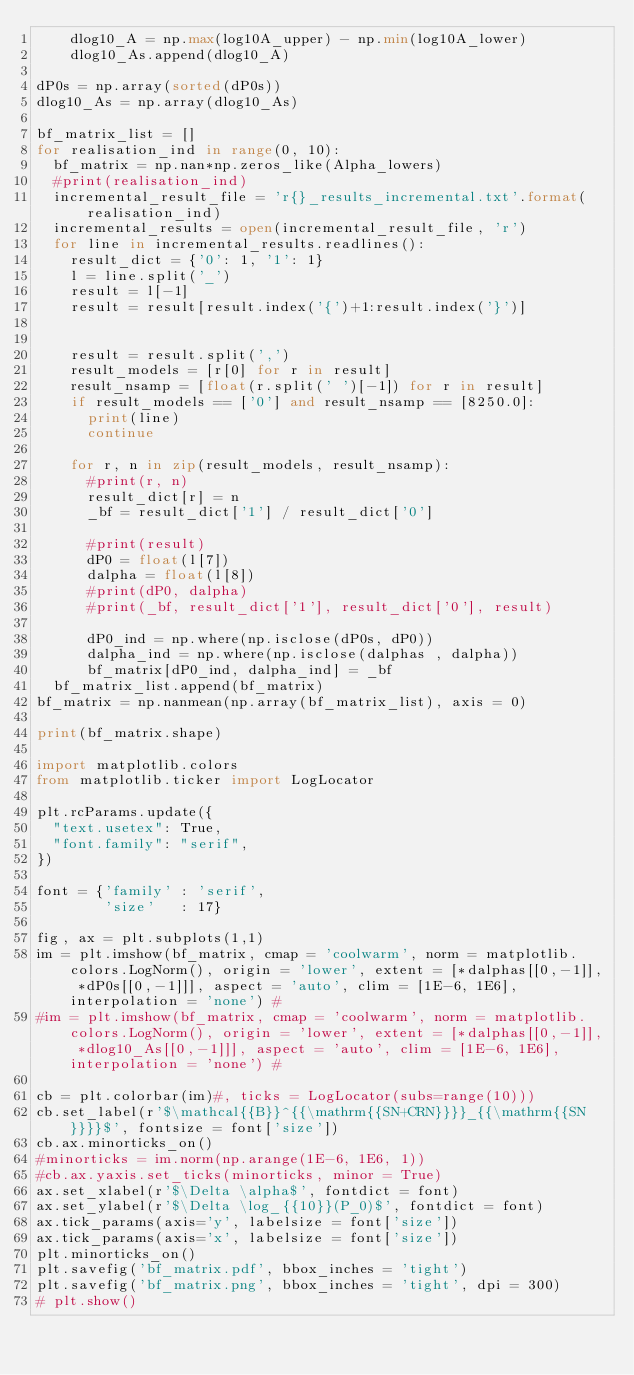Convert code to text. <code><loc_0><loc_0><loc_500><loc_500><_Python_>    dlog10_A = np.max(log10A_upper) - np.min(log10A_lower)
    dlog10_As.append(dlog10_A)

dP0s = np.array(sorted(dP0s))
dlog10_As = np.array(dlog10_As)

bf_matrix_list = []
for realisation_ind in range(0, 10):
  bf_matrix = np.nan*np.zeros_like(Alpha_lowers)
  #print(realisation_ind)
  incremental_result_file = 'r{}_results_incremental.txt'.format(realisation_ind)
  incremental_results = open(incremental_result_file, 'r')
  for line in incremental_results.readlines():
    result_dict = {'0': 1, '1': 1}
    l = line.split('_')
    result = l[-1]
    result = result[result.index('{')+1:result.index('}')]


    result = result.split(',')
    result_models = [r[0] for r in result]
    result_nsamp = [float(r.split(' ')[-1]) for r in result]
    if result_models == ['0'] and result_nsamp == [8250.0]:
      print(line)
      continue

    for r, n in zip(result_models, result_nsamp):
      #print(r, n)
      result_dict[r] = n
      _bf = result_dict['1'] / result_dict['0']

      #print(result)
      dP0 = float(l[7])
      dalpha = float(l[8])
      #print(dP0, dalpha)
      #print(_bf, result_dict['1'], result_dict['0'], result)

      dP0_ind = np.where(np.isclose(dP0s, dP0))
      dalpha_ind = np.where(np.isclose(dalphas , dalpha))
      bf_matrix[dP0_ind, dalpha_ind] = _bf
  bf_matrix_list.append(bf_matrix)
bf_matrix = np.nanmean(np.array(bf_matrix_list), axis = 0)

print(bf_matrix.shape)

import matplotlib.colors
from matplotlib.ticker import LogLocator

plt.rcParams.update({
  "text.usetex": True,
  "font.family": "serif",
})

font = {'family' : 'serif',
        'size'   : 17}

fig, ax = plt.subplots(1,1)
im = plt.imshow(bf_matrix, cmap = 'coolwarm', norm = matplotlib.colors.LogNorm(), origin = 'lower', extent = [*dalphas[[0,-1]], *dP0s[[0,-1]]], aspect = 'auto', clim = [1E-6, 1E6], interpolation = 'none') #
#im = plt.imshow(bf_matrix, cmap = 'coolwarm', norm = matplotlib.colors.LogNorm(), origin = 'lower', extent = [*dalphas[[0,-1]], *dlog10_As[[0,-1]]], aspect = 'auto', clim = [1E-6, 1E6], interpolation = 'none') #

cb = plt.colorbar(im)#, ticks = LogLocator(subs=range(10)))
cb.set_label(r'$\mathcal{{B}}^{{\mathrm{{SN+CRN}}}}_{{\mathrm{{SN}}}}$', fontsize = font['size'])
cb.ax.minorticks_on()
#minorticks = im.norm(np.arange(1E-6, 1E6, 1))
#cb.ax.yaxis.set_ticks(minorticks, minor = True)
ax.set_xlabel(r'$\Delta \alpha$', fontdict = font)
ax.set_ylabel(r'$\Delta \log_{{10}}(P_0)$', fontdict = font)
ax.tick_params(axis='y', labelsize = font['size'])
ax.tick_params(axis='x', labelsize = font['size'])
plt.minorticks_on()
plt.savefig('bf_matrix.pdf', bbox_inches = 'tight')
plt.savefig('bf_matrix.png', bbox_inches = 'tight', dpi = 300)
# plt.show()
</code> 